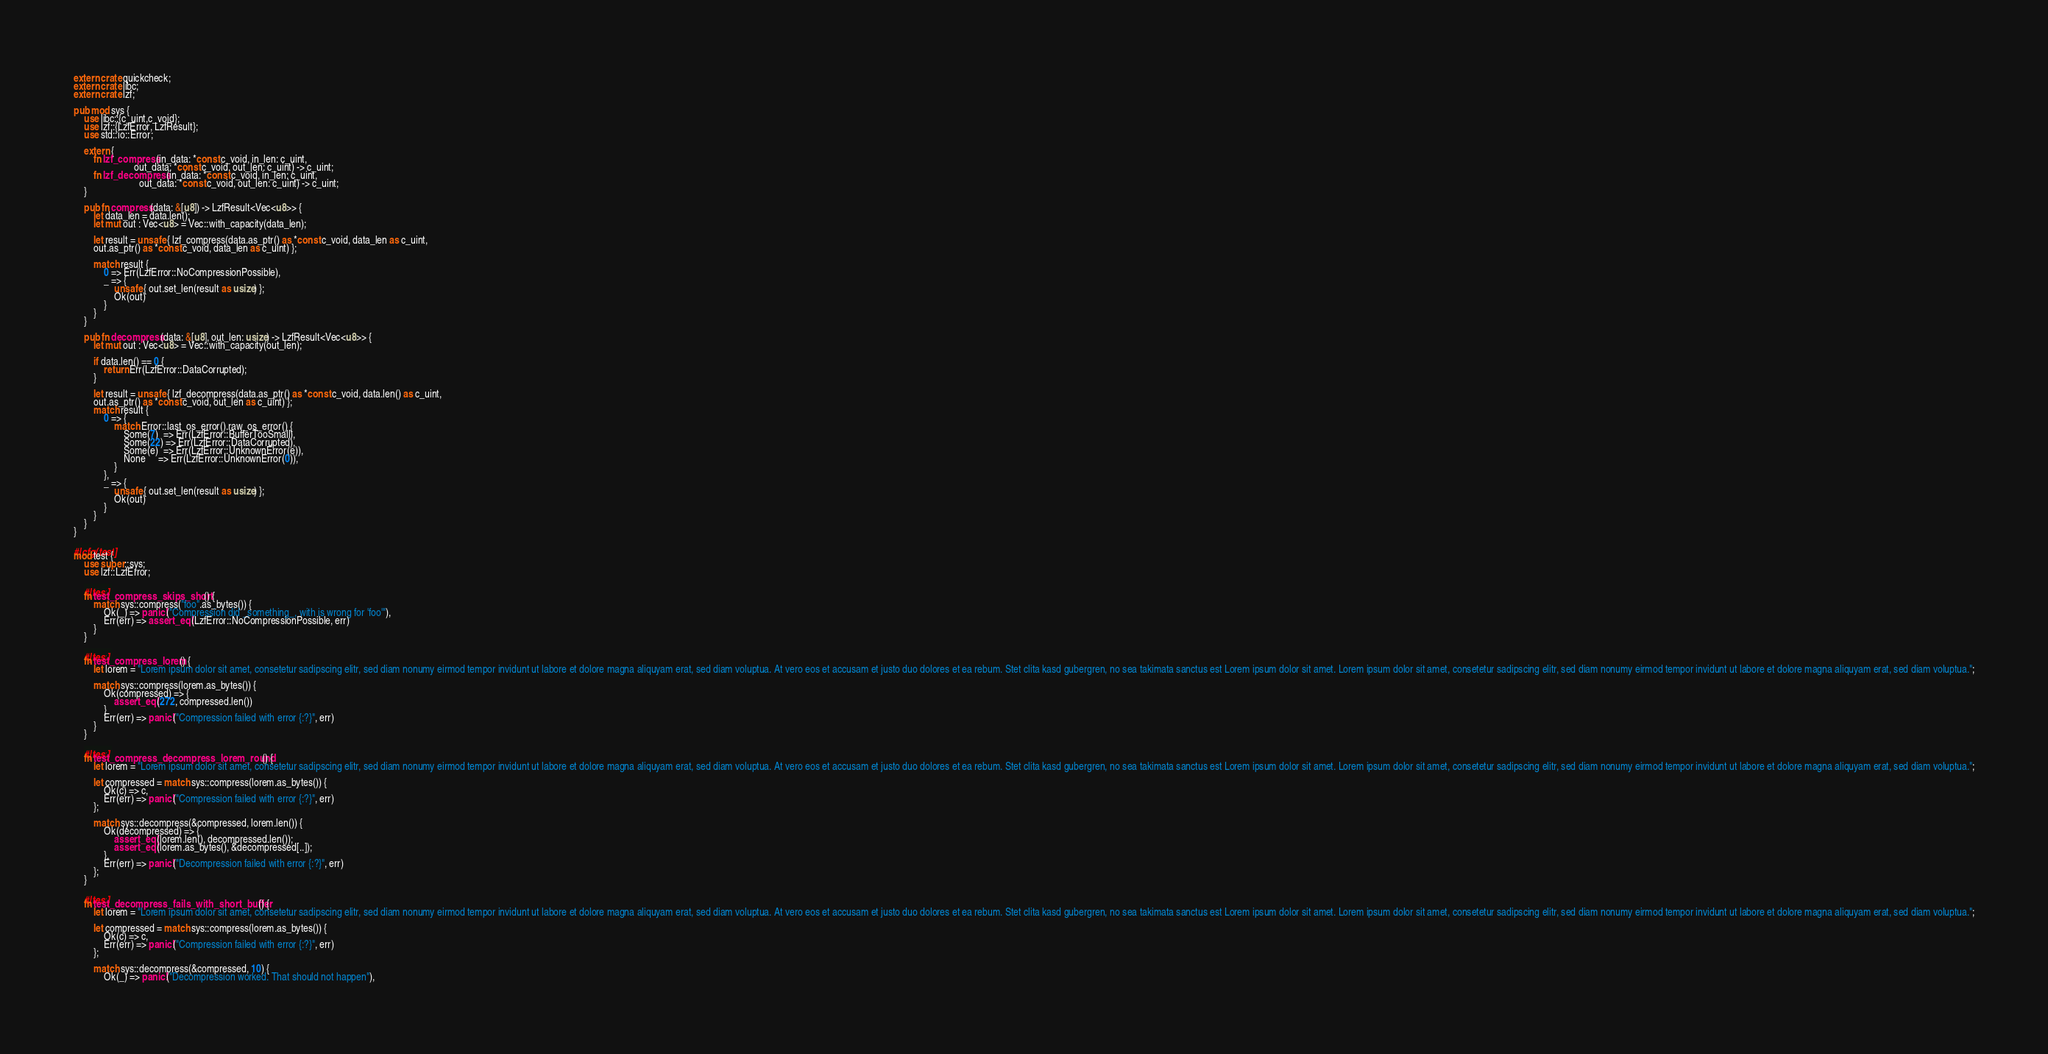<code> <loc_0><loc_0><loc_500><loc_500><_Rust_>extern crate quickcheck;
extern crate libc;
extern crate lzf;

pub mod sys {
    use libc::{c_uint,c_void};
    use lzf::{LzfError, LzfResult};
    use std::io::Error;

    extern {
        fn lzf_compress(in_data: *const c_void, in_len: c_uint,
                        out_data: *const c_void, out_len: c_uint) -> c_uint;
        fn lzf_decompress(in_data: *const c_void, in_len: c_uint,
                          out_data: *const c_void, out_len: c_uint) -> c_uint;
    }

    pub fn compress(data: &[u8]) -> LzfResult<Vec<u8>> {
        let data_len = data.len();
        let mut out : Vec<u8> = Vec::with_capacity(data_len);

        let result = unsafe { lzf_compress(data.as_ptr() as *const c_void, data_len as c_uint,
        out.as_ptr() as *const c_void, data_len as c_uint) };

        match result {
            0 => Err(LzfError::NoCompressionPossible),
            _ => {
                unsafe { out.set_len(result as usize) };
                Ok(out)
            }
        }
    }

    pub fn decompress(data: &[u8], out_len: usize) -> LzfResult<Vec<u8>> {
        let mut out : Vec<u8> = Vec::with_capacity(out_len);

        if data.len() == 0 {
            return Err(LzfError::DataCorrupted);
        }

        let result = unsafe { lzf_decompress(data.as_ptr() as *const c_void, data.len() as c_uint,
        out.as_ptr() as *const c_void, out_len as c_uint) };
        match result {
            0 => {
                match Error::last_os_error().raw_os_error() {
                    Some(7)  => Err(LzfError::BufferTooSmall),
                    Some(22) => Err(LzfError::DataCorrupted),
                    Some(e)  => Err(LzfError::UnknownError(e)),
                    None     => Err(LzfError::UnknownError(0)),
                }
            },
            _ => {
                unsafe { out.set_len(result as usize) };
                Ok(out)
            }
        }
    }
}

#[cfg(test)]
mod test {
    use super::sys;
    use lzf::LzfError;

    #[test]
    fn test_compress_skips_short() {
        match sys::compress("foo".as_bytes()) {
            Ok(_) => panic!("Compression did _something_, with is wrong for 'foo'"),
            Err(err) => assert_eq!(LzfError::NoCompressionPossible, err)
        }
    }

    #[test]
    fn test_compress_lorem() {
        let lorem = "Lorem ipsum dolor sit amet, consetetur sadipscing elitr, sed diam nonumy eirmod tempor invidunt ut labore et dolore magna aliquyam erat, sed diam voluptua. At vero eos et accusam et justo duo dolores et ea rebum. Stet clita kasd gubergren, no sea takimata sanctus est Lorem ipsum dolor sit amet. Lorem ipsum dolor sit amet, consetetur sadipscing elitr, sed diam nonumy eirmod tempor invidunt ut labore et dolore magna aliquyam erat, sed diam voluptua.";

        match sys::compress(lorem.as_bytes()) {
            Ok(compressed) => {
                assert_eq!(272, compressed.len())
            }
            Err(err) => panic!("Compression failed with error {:?}", err)
        }
    }

    #[test]
    fn test_compress_decompress_lorem_round() {
        let lorem = "Lorem ipsum dolor sit amet, consetetur sadipscing elitr, sed diam nonumy eirmod tempor invidunt ut labore et dolore magna aliquyam erat, sed diam voluptua. At vero eos et accusam et justo duo dolores et ea rebum. Stet clita kasd gubergren, no sea takimata sanctus est Lorem ipsum dolor sit amet. Lorem ipsum dolor sit amet, consetetur sadipscing elitr, sed diam nonumy eirmod tempor invidunt ut labore et dolore magna aliquyam erat, sed diam voluptua.";

        let compressed = match sys::compress(lorem.as_bytes()) {
            Ok(c) => c,
            Err(err) => panic!("Compression failed with error {:?}", err)
        };

        match sys::decompress(&compressed, lorem.len()) {
            Ok(decompressed) => {
                assert_eq!(lorem.len(), decompressed.len());
                assert_eq!(lorem.as_bytes(), &decompressed[..]);
            },
            Err(err) => panic!("Decompression failed with error {:?}", err)
        };
    }

    #[test]
    fn test_decompress_fails_with_short_buffer() {
        let lorem = "Lorem ipsum dolor sit amet, consetetur sadipscing elitr, sed diam nonumy eirmod tempor invidunt ut labore et dolore magna aliquyam erat, sed diam voluptua. At vero eos et accusam et justo duo dolores et ea rebum. Stet clita kasd gubergren, no sea takimata sanctus est Lorem ipsum dolor sit amet. Lorem ipsum dolor sit amet, consetetur sadipscing elitr, sed diam nonumy eirmod tempor invidunt ut labore et dolore magna aliquyam erat, sed diam voluptua.";

        let compressed = match sys::compress(lorem.as_bytes()) {
            Ok(c) => c,
            Err(err) => panic!("Compression failed with error {:?}", err)
        };

        match sys::decompress(&compressed, 10) {
            Ok(_) => panic!("Decompression worked. That should not happen"),</code> 